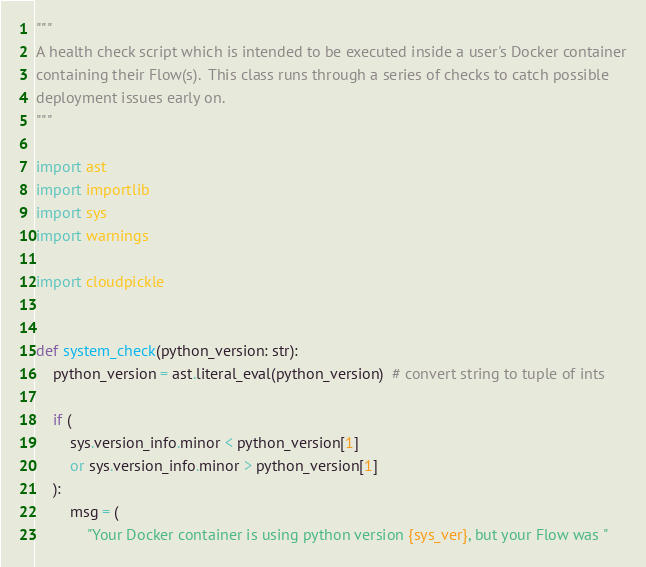<code> <loc_0><loc_0><loc_500><loc_500><_Python_>"""
A health check script which is intended to be executed inside a user's Docker container
containing their Flow(s).  This class runs through a series of checks to catch possible
deployment issues early on.
"""

import ast
import importlib
import sys
import warnings

import cloudpickle


def system_check(python_version: str):
    python_version = ast.literal_eval(python_version)  # convert string to tuple of ints

    if (
        sys.version_info.minor < python_version[1]
        or sys.version_info.minor > python_version[1]
    ):
        msg = (
            "Your Docker container is using python version {sys_ver}, but your Flow was "</code> 